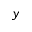<formula> <loc_0><loc_0><loc_500><loc_500>y</formula> 